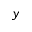<formula> <loc_0><loc_0><loc_500><loc_500>y</formula> 